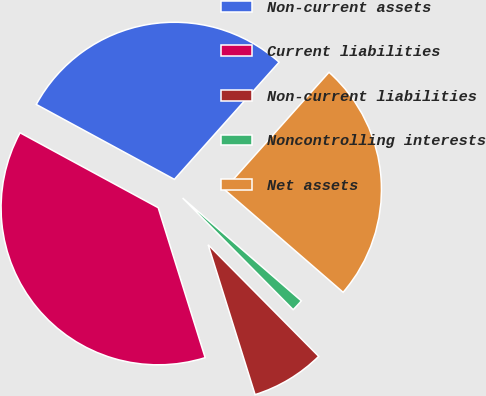Convert chart. <chart><loc_0><loc_0><loc_500><loc_500><pie_chart><fcel>Non-current assets<fcel>Current liabilities<fcel>Non-current liabilities<fcel>Noncontrolling interests<fcel>Net assets<nl><fcel>28.69%<fcel>37.74%<fcel>7.59%<fcel>1.22%<fcel>24.75%<nl></chart> 